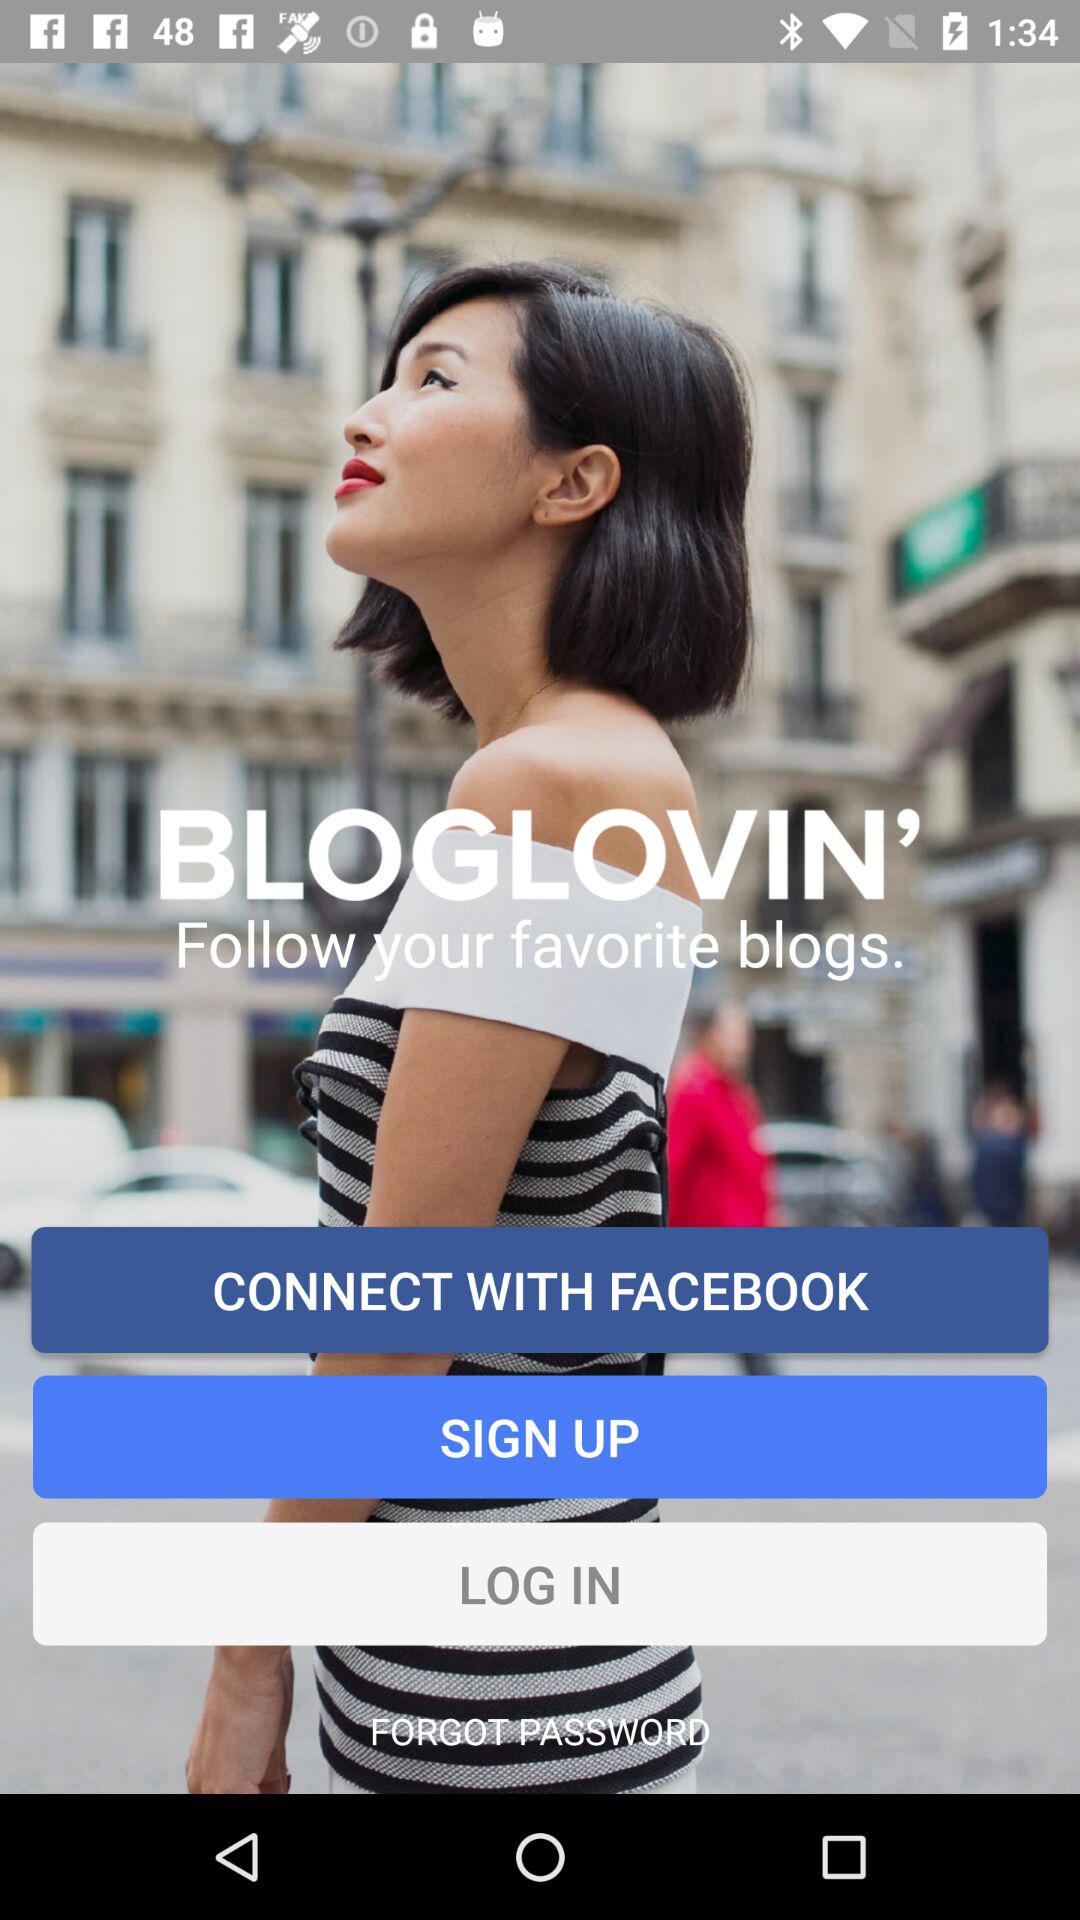What other options does the user have for interacting with the platform shown in the image? Besides connecting through Facebook, the user can also choose to sign up for a new account or log in to an existing account, as indicated by the 'SIGN UP' and 'LOG IN' buttons. There's also an option for users who may have forgotten their password, with a 'FORGOT PASSWORD' link provided. 